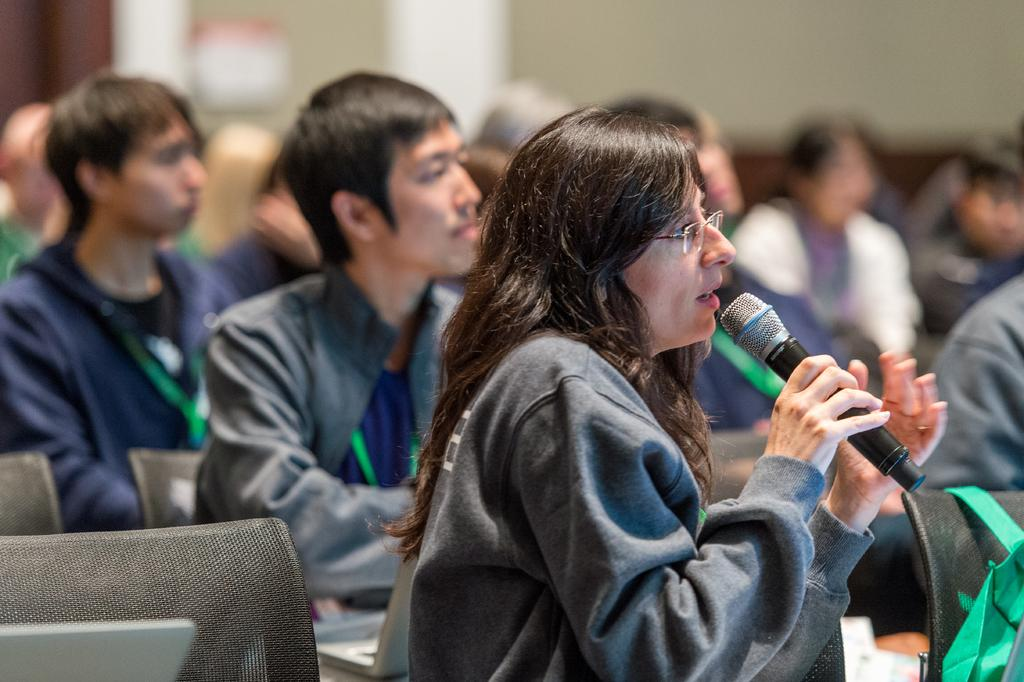What is the woman in the image holding? The woman is holding a mic. Can you describe the woman's appearance? The woman is wearing glasses. What is the woman doing in the image? The woman is talking. What can be seen in the background of the image? There are many persons sitting in the background, and there are many chairs as well. What type of linen is being used to cover the son in the image? There is no son or linen present in the image. 